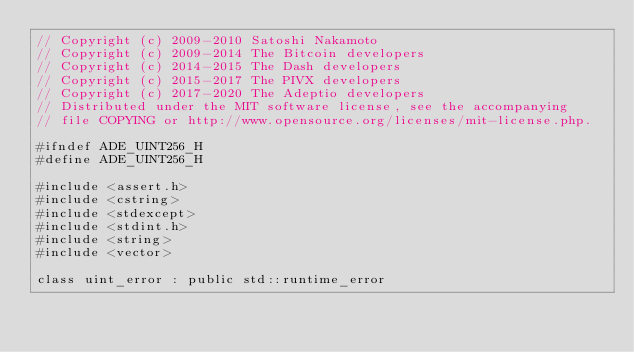<code> <loc_0><loc_0><loc_500><loc_500><_C_>// Copyright (c) 2009-2010 Satoshi Nakamoto
// Copyright (c) 2009-2014 The Bitcoin developers
// Copyright (c) 2014-2015 The Dash developers
// Copyright (c) 2015-2017 The PIVX developers// Copyright (c) 2017-2020 The Adeptio developers
// Distributed under the MIT software license, see the accompanying
// file COPYING or http://www.opensource.org/licenses/mit-license.php.

#ifndef ADE_UINT256_H
#define ADE_UINT256_H

#include <assert.h>
#include <cstring>
#include <stdexcept>
#include <stdint.h>
#include <string>
#include <vector>

class uint_error : public std::runtime_error</code> 